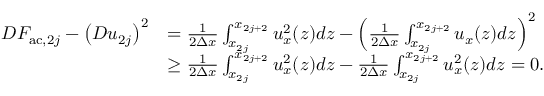Convert formula to latex. <formula><loc_0><loc_0><loc_500><loc_500>\begin{array} { r l } { D F _ { a c , 2 j } - \left ( D u _ { 2 j } \right ) ^ { 2 } } & { = \frac { 1 } { 2 \Delta x } \int _ { x _ { 2 j } } ^ { x _ { 2 j + 2 } } u _ { x } ^ { 2 } ( z ) d z - \left ( \frac { 1 } { 2 \Delta x } \int _ { x _ { 2 j } } ^ { x _ { 2 j + 2 } } u _ { x } ( z ) d z \right ) ^ { 2 } } \\ & { \geq \frac { 1 } { 2 \Delta x } \int _ { x _ { 2 j } } ^ { x _ { 2 j + 2 } } u _ { x } ^ { 2 } ( z ) d z - \frac { 1 } { 2 \Delta x } \int _ { x _ { 2 j } } ^ { x _ { 2 j + 2 } } u _ { x } ^ { 2 } ( z ) d z = 0 . } \end{array}</formula> 